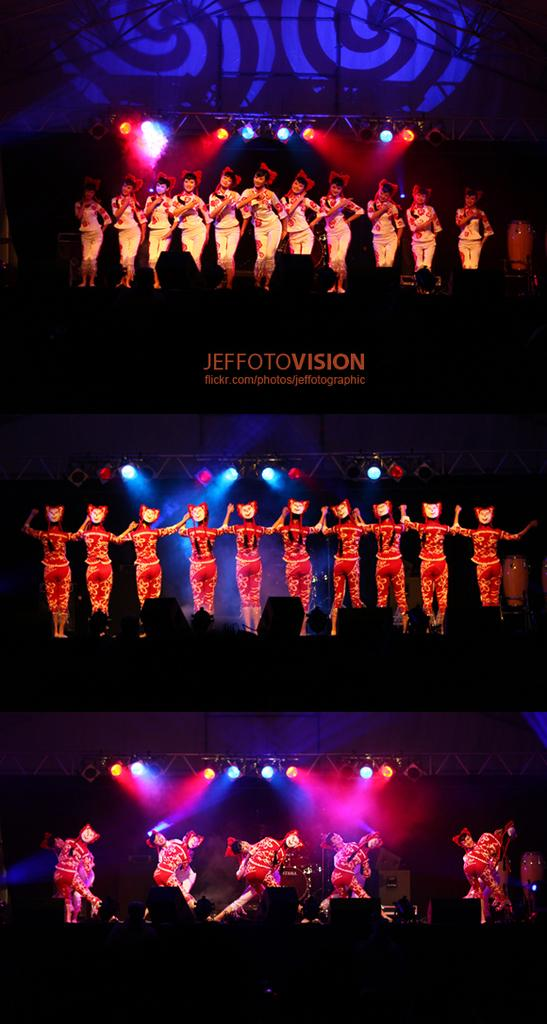What is the main subject of the collage in the image? The image contains a collage of three pictures. What is happening in the pictures of the collage? There are people performing on a stage in the collage. What can be seen in addition to the people performing on stage? There are lights visible in the collage. Is there any text present in the collage? Yes, there is text present in the collage. What type of bread is being used as a prop by the performers in the image? There is no bread present in the image; it features a collage of three pictures with people performing on stage, lights, and text. 